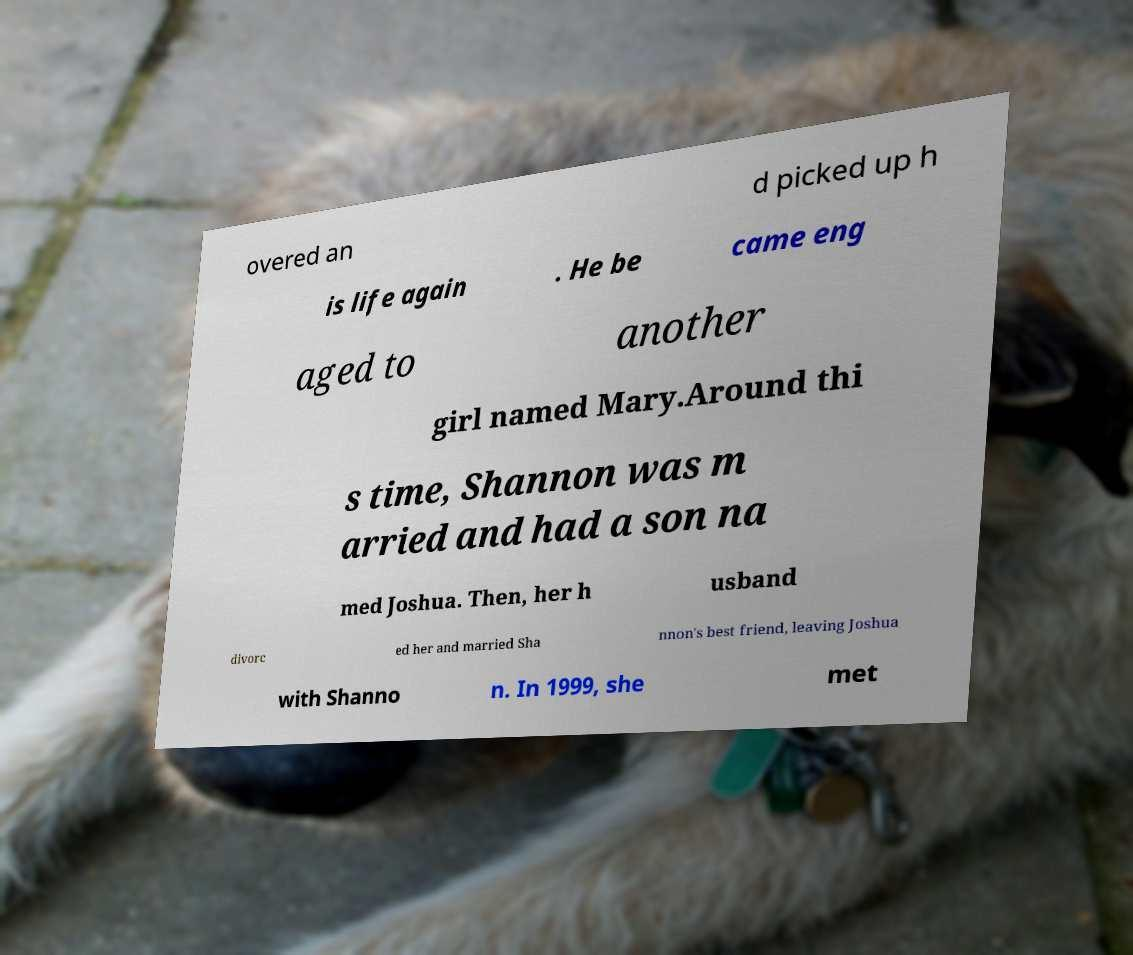Please identify and transcribe the text found in this image. overed an d picked up h is life again . He be came eng aged to another girl named Mary.Around thi s time, Shannon was m arried and had a son na med Joshua. Then, her h usband divorc ed her and married Sha nnon's best friend, leaving Joshua with Shanno n. In 1999, she met 